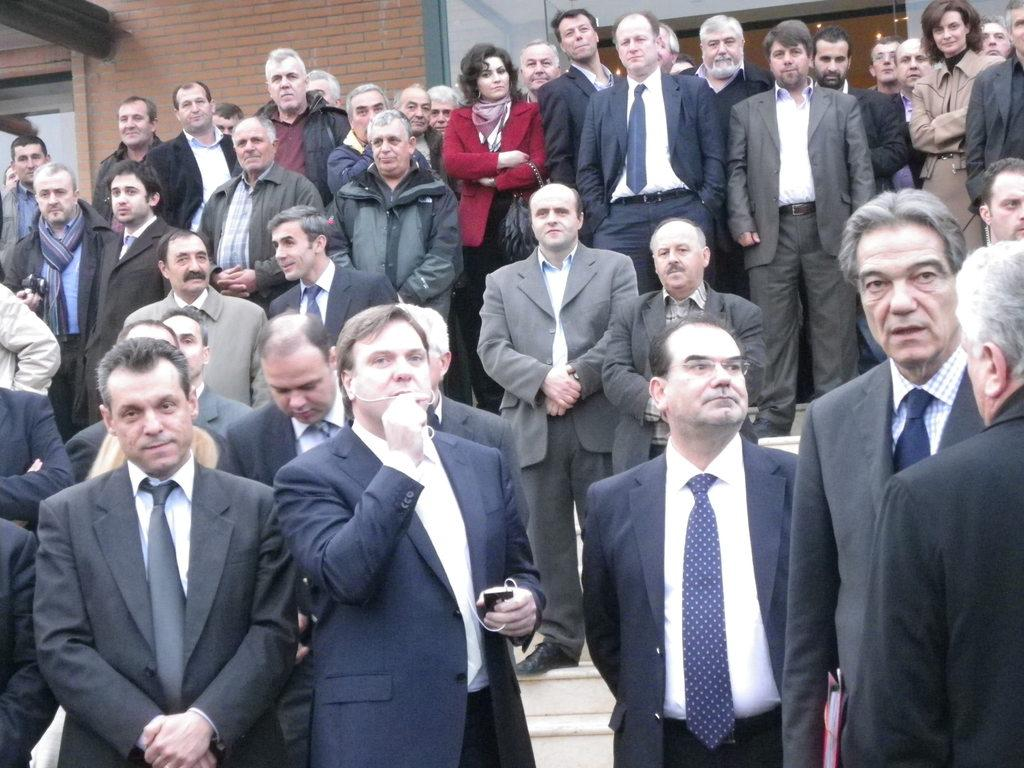How many people are in the image? There is a group of people in the image. What are some of the people wearing? Some of the people are wearing suits. What can be seen in the background of the image? There is a brick wall in the background of the image. Can you see any stars in the image? There are no stars visible in the image; it features a group of people and a brick wall in the background. 